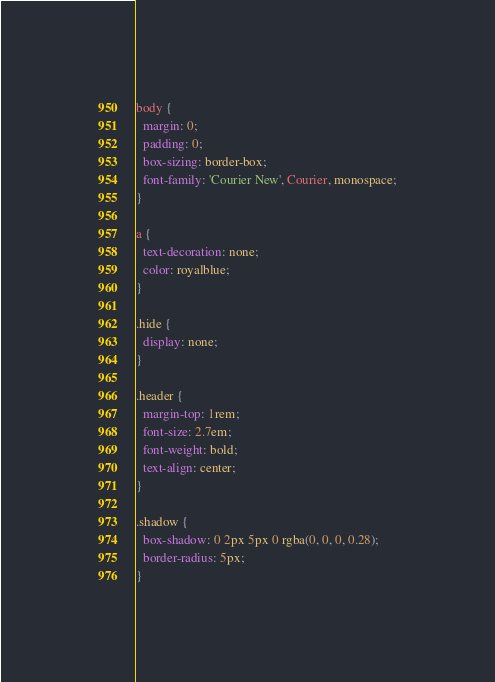Convert code to text. <code><loc_0><loc_0><loc_500><loc_500><_CSS_>body {
  margin: 0;
  padding: 0;
  box-sizing: border-box;
  font-family: 'Courier New', Courier, monospace;
}

a {
  text-decoration: none;
  color: royalblue;
}

.hide {
  display: none;
}

.header {
  margin-top: 1rem;
  font-size: 2.7em;
  font-weight: bold;
  text-align: center;
}

.shadow {
  box-shadow: 0 2px 5px 0 rgba(0, 0, 0, 0.28);
  border-radius: 5px;
}
</code> 